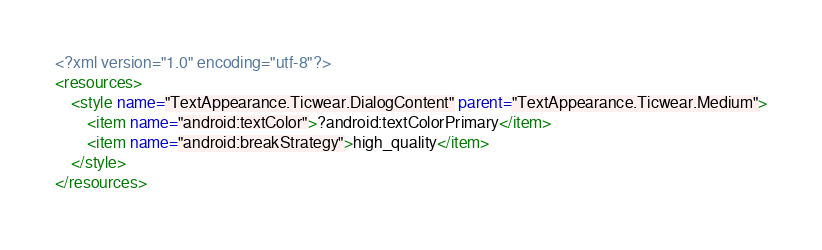<code> <loc_0><loc_0><loc_500><loc_500><_XML_><?xml version="1.0" encoding="utf-8"?>
<resources>
    <style name="TextAppearance.Ticwear.DialogContent" parent="TextAppearance.Ticwear.Medium">
        <item name="android:textColor">?android:textColorPrimary</item>
        <item name="android:breakStrategy">high_quality</item>
    </style>
</resources></code> 